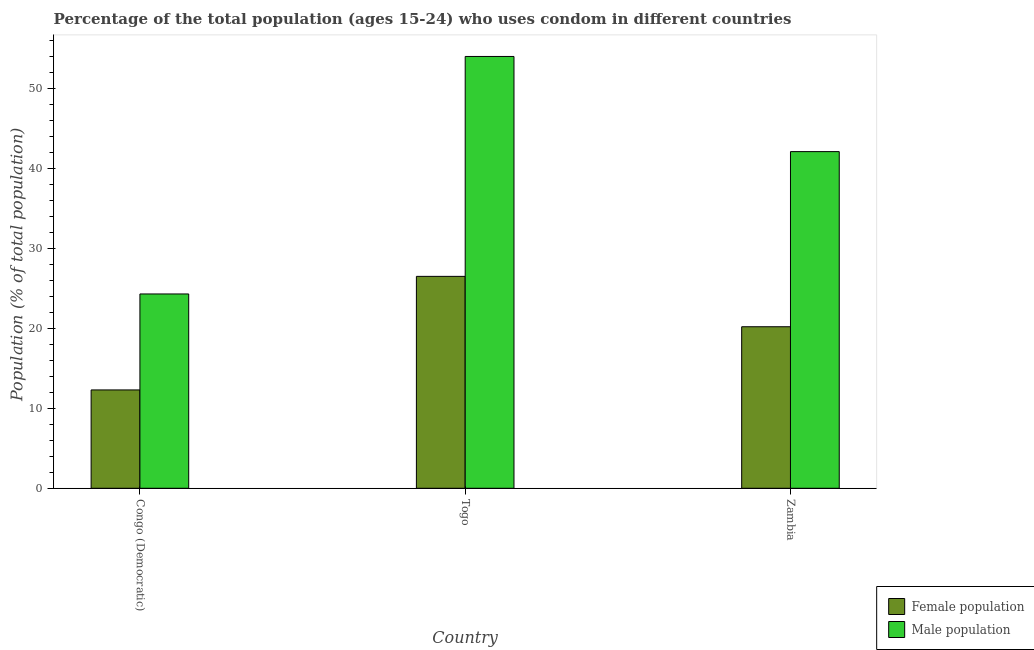Are the number of bars per tick equal to the number of legend labels?
Offer a very short reply. Yes. How many bars are there on the 1st tick from the left?
Your answer should be very brief. 2. How many bars are there on the 2nd tick from the right?
Your answer should be compact. 2. What is the label of the 2nd group of bars from the left?
Keep it short and to the point. Togo. In how many cases, is the number of bars for a given country not equal to the number of legend labels?
Make the answer very short. 0. What is the female population in Zambia?
Provide a short and direct response. 20.2. Across all countries, what is the minimum male population?
Offer a very short reply. 24.3. In which country was the female population maximum?
Offer a very short reply. Togo. In which country was the male population minimum?
Ensure brevity in your answer.  Congo (Democratic). What is the difference between the male population in Togo and that in Zambia?
Keep it short and to the point. 11.9. What is the difference between the male population in Togo and the female population in Congo (Democratic)?
Provide a short and direct response. 41.7. What is the average female population per country?
Provide a succinct answer. 19.67. What is the difference between the male population and female population in Zambia?
Provide a short and direct response. 21.9. What is the ratio of the female population in Congo (Democratic) to that in Togo?
Keep it short and to the point. 0.46. Is the difference between the female population in Congo (Democratic) and Zambia greater than the difference between the male population in Congo (Democratic) and Zambia?
Give a very brief answer. Yes. What is the difference between the highest and the second highest male population?
Ensure brevity in your answer.  11.9. What is the difference between the highest and the lowest male population?
Keep it short and to the point. 29.7. Is the sum of the female population in Congo (Democratic) and Togo greater than the maximum male population across all countries?
Your answer should be compact. No. What does the 1st bar from the left in Togo represents?
Your response must be concise. Female population. What does the 2nd bar from the right in Togo represents?
Offer a terse response. Female population. How many bars are there?
Offer a terse response. 6. Are all the bars in the graph horizontal?
Provide a short and direct response. No. Are the values on the major ticks of Y-axis written in scientific E-notation?
Offer a very short reply. No. Does the graph contain any zero values?
Ensure brevity in your answer.  No. What is the title of the graph?
Make the answer very short. Percentage of the total population (ages 15-24) who uses condom in different countries. What is the label or title of the Y-axis?
Offer a terse response. Population (% of total population) . What is the Population (% of total population)  of Female population in Congo (Democratic)?
Offer a terse response. 12.3. What is the Population (% of total population)  in Male population in Congo (Democratic)?
Your response must be concise. 24.3. What is the Population (% of total population)  of Male population in Togo?
Ensure brevity in your answer.  54. What is the Population (% of total population)  of Female population in Zambia?
Ensure brevity in your answer.  20.2. What is the Population (% of total population)  of Male population in Zambia?
Your answer should be very brief. 42.1. Across all countries, what is the maximum Population (% of total population)  of Male population?
Give a very brief answer. 54. Across all countries, what is the minimum Population (% of total population)  in Female population?
Provide a succinct answer. 12.3. Across all countries, what is the minimum Population (% of total population)  in Male population?
Your response must be concise. 24.3. What is the total Population (% of total population)  of Female population in the graph?
Give a very brief answer. 59. What is the total Population (% of total population)  in Male population in the graph?
Provide a short and direct response. 120.4. What is the difference between the Population (% of total population)  in Female population in Congo (Democratic) and that in Togo?
Make the answer very short. -14.2. What is the difference between the Population (% of total population)  in Male population in Congo (Democratic) and that in Togo?
Ensure brevity in your answer.  -29.7. What is the difference between the Population (% of total population)  in Male population in Congo (Democratic) and that in Zambia?
Ensure brevity in your answer.  -17.8. What is the difference between the Population (% of total population)  of Male population in Togo and that in Zambia?
Ensure brevity in your answer.  11.9. What is the difference between the Population (% of total population)  in Female population in Congo (Democratic) and the Population (% of total population)  in Male population in Togo?
Make the answer very short. -41.7. What is the difference between the Population (% of total population)  of Female population in Congo (Democratic) and the Population (% of total population)  of Male population in Zambia?
Provide a short and direct response. -29.8. What is the difference between the Population (% of total population)  in Female population in Togo and the Population (% of total population)  in Male population in Zambia?
Provide a succinct answer. -15.6. What is the average Population (% of total population)  in Female population per country?
Make the answer very short. 19.67. What is the average Population (% of total population)  of Male population per country?
Offer a terse response. 40.13. What is the difference between the Population (% of total population)  in Female population and Population (% of total population)  in Male population in Togo?
Your answer should be compact. -27.5. What is the difference between the Population (% of total population)  in Female population and Population (% of total population)  in Male population in Zambia?
Make the answer very short. -21.9. What is the ratio of the Population (% of total population)  in Female population in Congo (Democratic) to that in Togo?
Make the answer very short. 0.46. What is the ratio of the Population (% of total population)  in Male population in Congo (Democratic) to that in Togo?
Offer a very short reply. 0.45. What is the ratio of the Population (% of total population)  in Female population in Congo (Democratic) to that in Zambia?
Your answer should be compact. 0.61. What is the ratio of the Population (% of total population)  of Male population in Congo (Democratic) to that in Zambia?
Offer a very short reply. 0.58. What is the ratio of the Population (% of total population)  of Female population in Togo to that in Zambia?
Make the answer very short. 1.31. What is the ratio of the Population (% of total population)  in Male population in Togo to that in Zambia?
Keep it short and to the point. 1.28. What is the difference between the highest and the second highest Population (% of total population)  of Female population?
Ensure brevity in your answer.  6.3. What is the difference between the highest and the lowest Population (% of total population)  in Male population?
Offer a very short reply. 29.7. 